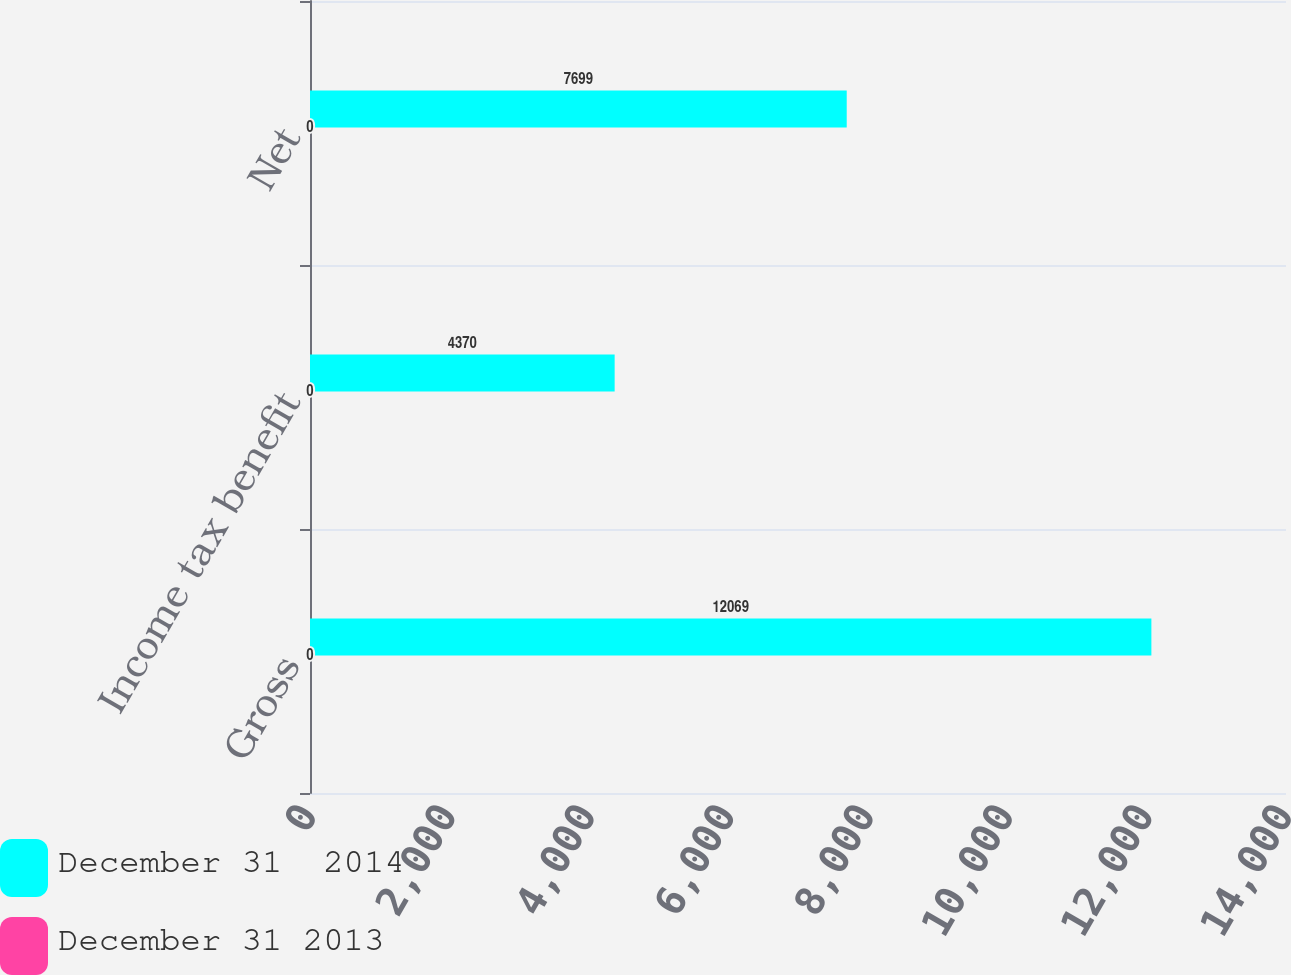<chart> <loc_0><loc_0><loc_500><loc_500><stacked_bar_chart><ecel><fcel>Gross<fcel>Income tax benefit<fcel>Net<nl><fcel>December 31  2014<fcel>12069<fcel>4370<fcel>7699<nl><fcel>December 31 2013<fcel>0<fcel>0<fcel>0<nl></chart> 